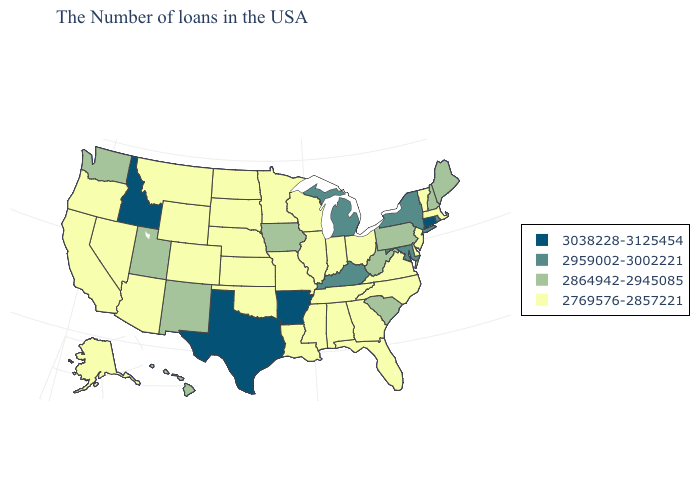Does Ohio have a lower value than South Carolina?
Give a very brief answer. Yes. Name the states that have a value in the range 3038228-3125454?
Quick response, please. Connecticut, Arkansas, Texas, Idaho. Does Minnesota have the same value as Kansas?
Be succinct. Yes. Does New Hampshire have the highest value in the USA?
Answer briefly. No. Does Arkansas have the highest value in the South?
Be succinct. Yes. Among the states that border Kentucky , does West Virginia have the lowest value?
Be succinct. No. What is the value of Utah?
Write a very short answer. 2864942-2945085. What is the highest value in the MidWest ?
Short answer required. 2959002-3002221. Does Nevada have the same value as Kentucky?
Keep it brief. No. Does the first symbol in the legend represent the smallest category?
Short answer required. No. What is the value of Wisconsin?
Write a very short answer. 2769576-2857221. What is the lowest value in the USA?
Give a very brief answer. 2769576-2857221. Name the states that have a value in the range 3038228-3125454?
Answer briefly. Connecticut, Arkansas, Texas, Idaho. Name the states that have a value in the range 2959002-3002221?
Keep it brief. Rhode Island, New York, Maryland, Michigan, Kentucky. What is the value of Alabama?
Be succinct. 2769576-2857221. 